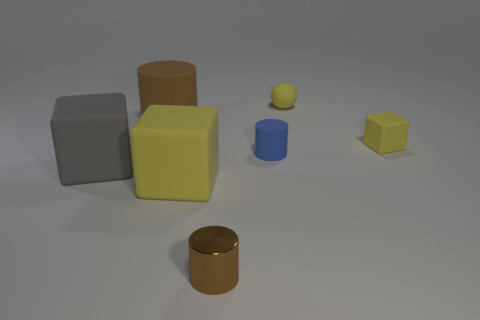Can you suggest a real-world application where these objects might be used? These objects could be used for educational purposes, like teaching geometry or demonstrating principles of light and shadow in art classes. They could also serve as models for product design or computer graphics projects. 